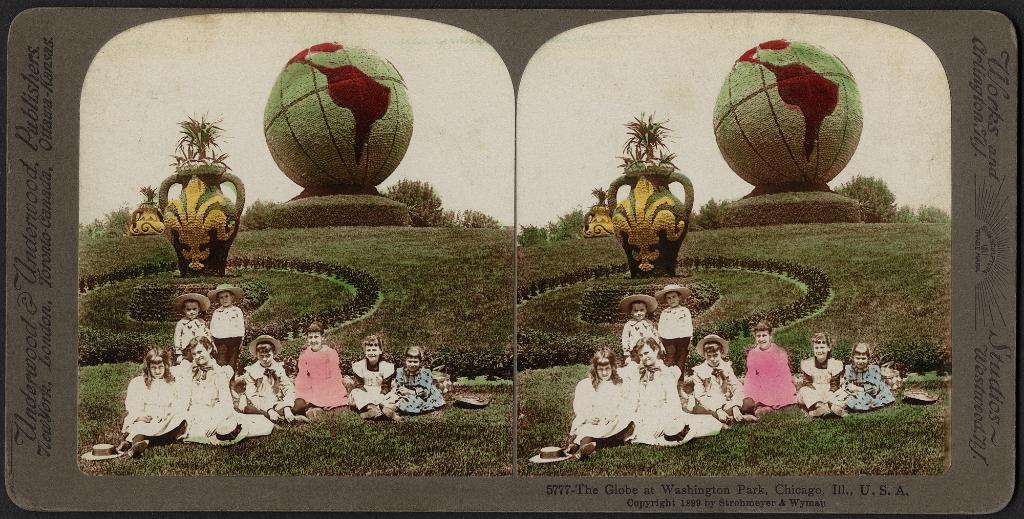What is the main subject of the board in the image? The board has photos and text in the image. What can be seen in the photos on the board? The photos on the board show people on the grass, plants, sculptures, trees, and the sky. What type of environment are the people in the photos located in? The people in the photos are on the grass, surrounded by plants, sculptures, trees, and the sky. How many fish can be seen swimming in the photos on the board? There are no fish visible in the photos on the board; they show people on the grass, plants, sculptures, trees, and the sky. 